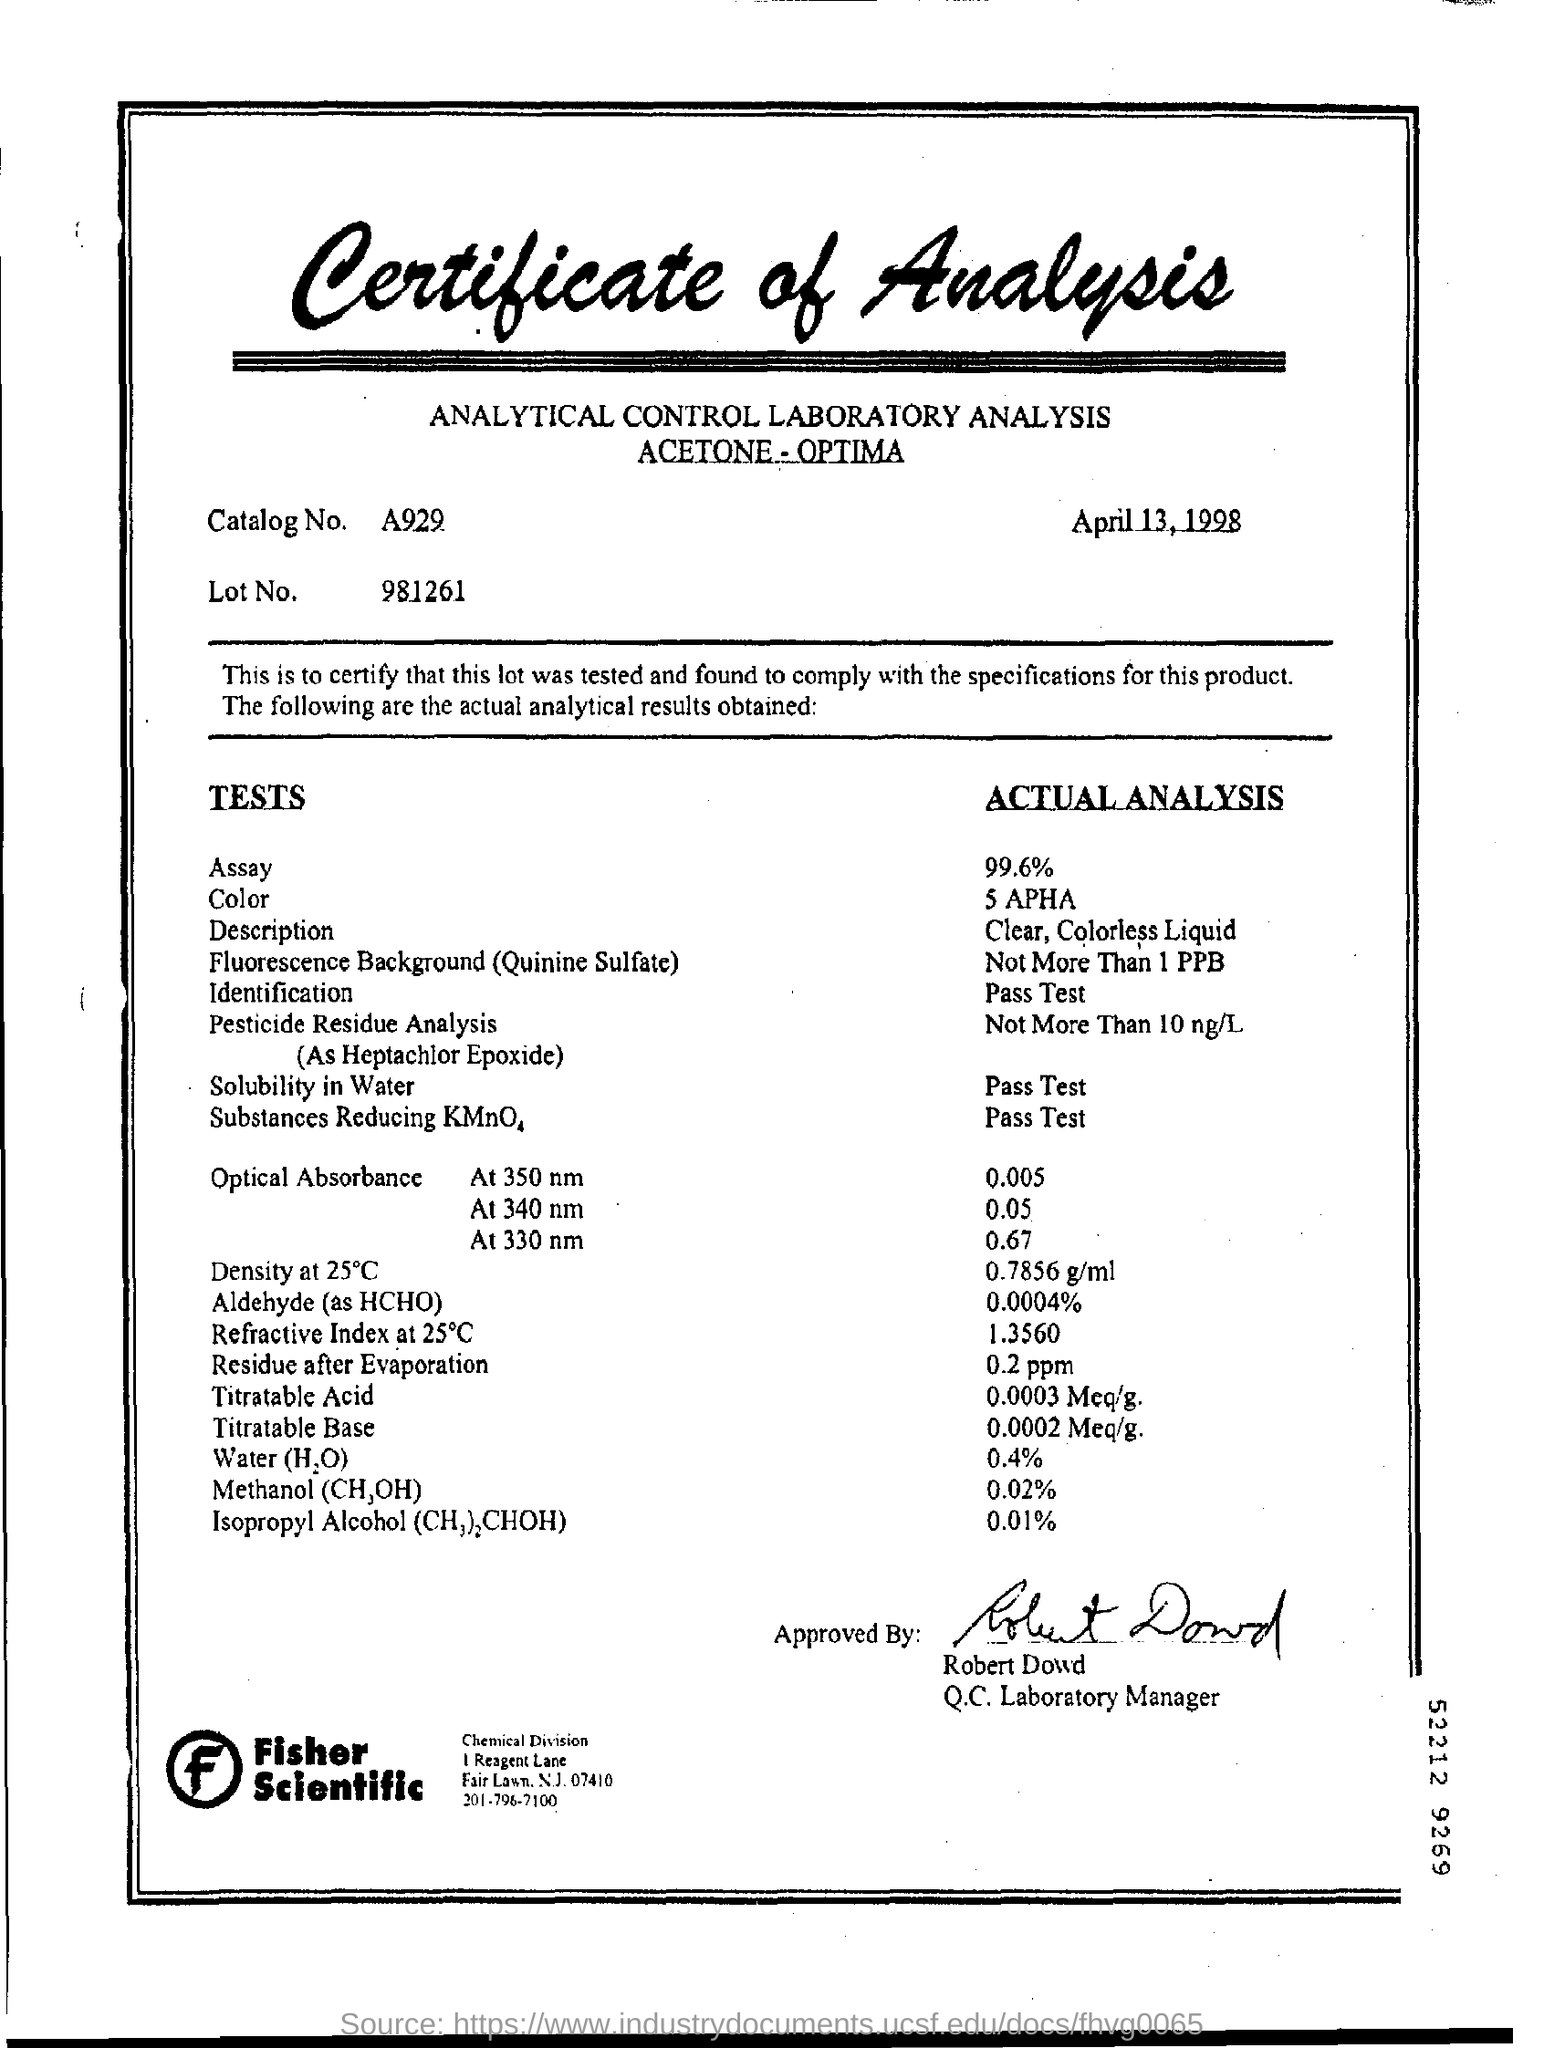Point out several critical features in this image. The "Titratable Acid" in the sample is 0.0003 Meq/g. The lot number is 981261... The catalog number is A929. The Certificate has been approved by Robert Dowd. Water (H2O) is composed of 0.4% of its actual analysis. 